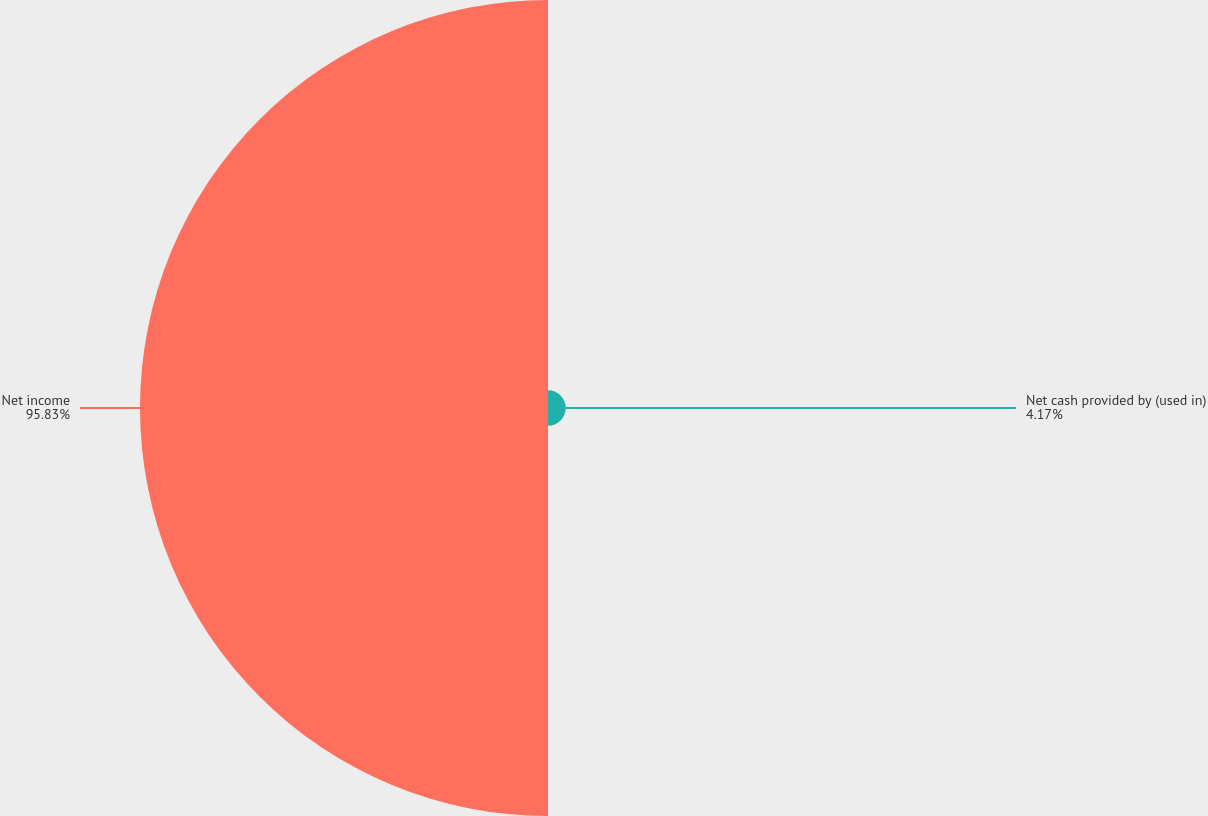<chart> <loc_0><loc_0><loc_500><loc_500><pie_chart><fcel>Net cash provided by (used in)<fcel>Net income<nl><fcel>4.17%<fcel>95.83%<nl></chart> 